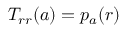<formula> <loc_0><loc_0><loc_500><loc_500>T _ { r r } ( a ) = p _ { a } ( r )</formula> 